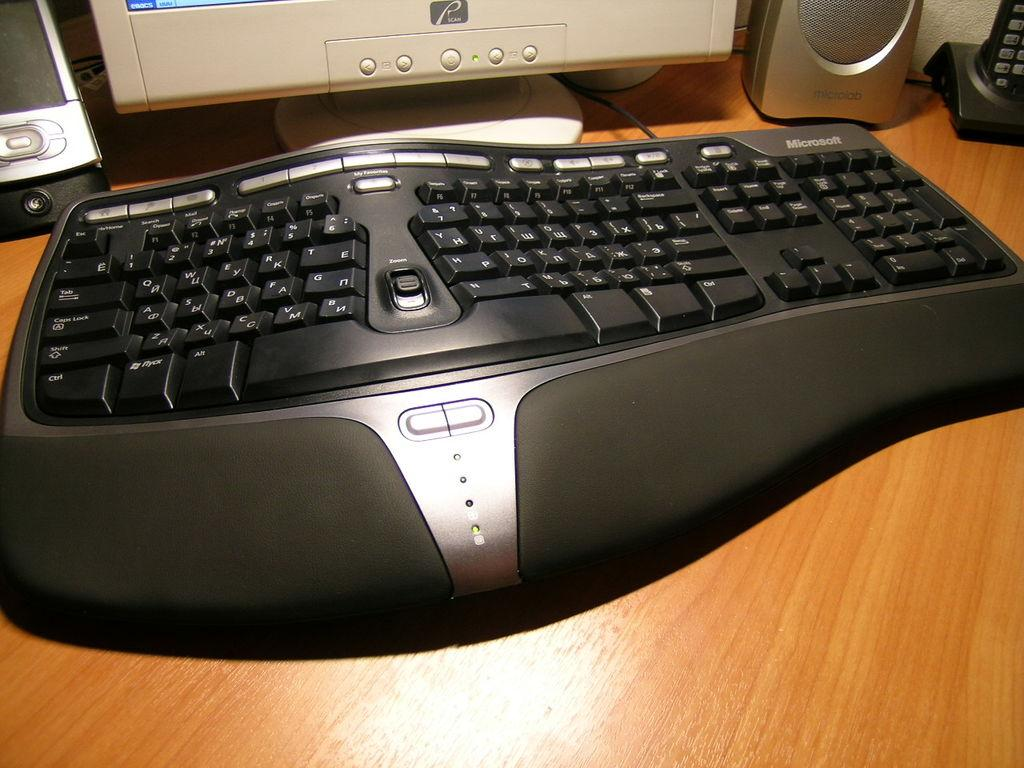Provide a one-sentence caption for the provided image. A split computer keyboard is in front of a monitor with a "scan" sticker. 